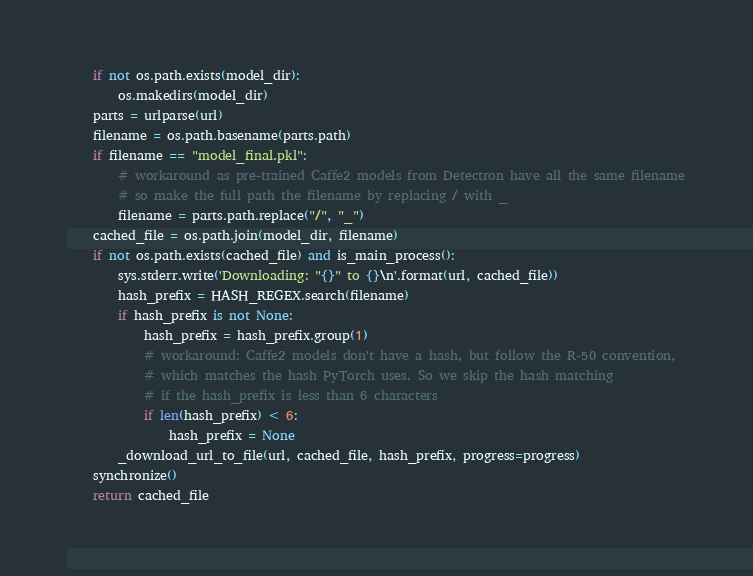Convert code to text. <code><loc_0><loc_0><loc_500><loc_500><_Python_>    if not os.path.exists(model_dir):
        os.makedirs(model_dir)
    parts = urlparse(url)
    filename = os.path.basename(parts.path)
    if filename == "model_final.pkl":
        # workaround as pre-trained Caffe2 models from Detectron have all the same filename
        # so make the full path the filename by replacing / with _
        filename = parts.path.replace("/", "_")
    cached_file = os.path.join(model_dir, filename)
    if not os.path.exists(cached_file) and is_main_process():
        sys.stderr.write('Downloading: "{}" to {}\n'.format(url, cached_file))
        hash_prefix = HASH_REGEX.search(filename)
        if hash_prefix is not None:
            hash_prefix = hash_prefix.group(1)
            # workaround: Caffe2 models don't have a hash, but follow the R-50 convention,
            # which matches the hash PyTorch uses. So we skip the hash matching
            # if the hash_prefix is less than 6 characters
            if len(hash_prefix) < 6:
                hash_prefix = None
        _download_url_to_file(url, cached_file, hash_prefix, progress=progress)
    synchronize()
    return cached_file
</code> 